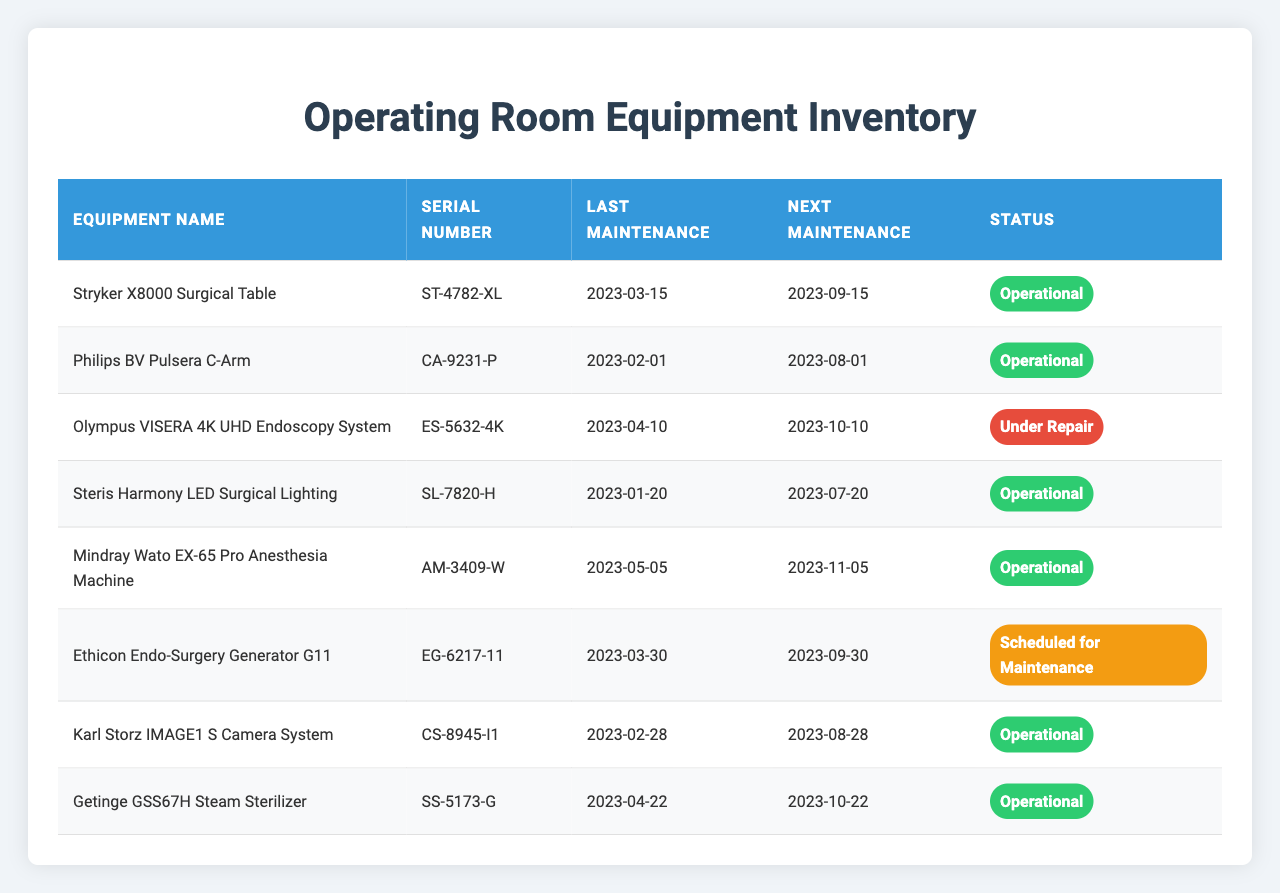What is the status of the Stryker X8000 Surgical Table? The status column in the table shows that the Stryker X8000 Surgical Table is labeled as "Operational."
Answer: Operational When is the next maintenance scheduled for the Philips BV Pulsera C-Arm? The next maintenance for the Philips BV Pulsera C-Arm is scheduled for August 1, 2023, as indicated in the nextMaintenance column.
Answer: August 1, 2023 How many pieces of equipment are currently under repair? By checking the status column, there is only one piece of equipment, the Olympus VISERA 4K UHD Endoscopy System, that is marked as "Under Repair."
Answer: 1 What is the last maintenance date for the Ethicon Endo-Surgery Generator G11? According to the table, the last maintenance date for the Ethicon Endo-Surgery Generator G11 is March 30, 2023.
Answer: March 30, 2023 Is the Getinge GSS67H Steam Sterilizer operational? The status column states that the Getinge GSS67H Steam Sterilizer is "Operational." Therefore, the answer is yes.
Answer: Yes Which equipment has the latest next maintenance date? To find this, compare the next maintenance dates: the latest date is for the Mindray Wato EX-65 Pro Anesthesia Machine on November 5, 2023.
Answer: November 5, 2023 How many pieces of equipment require maintenance before the end of September 2023? The pieces of equipment needing maintenance before September include the Stryker X8000 Surgical Table, Ethicon Endo-Surgery Generator G11, and Philips BV Pulsera C-Arm. That totals to three.
Answer: 3 What is the time interval between the last maintenance and next maintenance for the Steris Harmony LED Surgical Lighting? The last maintenance was on January 20, 2023, and the next is on July 20, 2023. The interval is 6 months.
Answer: 6 months Which equipment would need attention next, based on the schedule and status? The Ethicon Endo-Surgery Generator G11 is "Scheduled for Maintenance" and has the next date of September 30, so it needs attention next.
Answer: Ethicon Endo-Surgery Generator G11 If the Olympus VISERA 4K UHD Endoscopy System was under repair for four months, when was its last maintenance? Given the status of "Under Repair" and the next maintenance on October 10, 2023, the last maintenance would be June 10, 2023 (four months prior).
Answer: June 10, 2023 